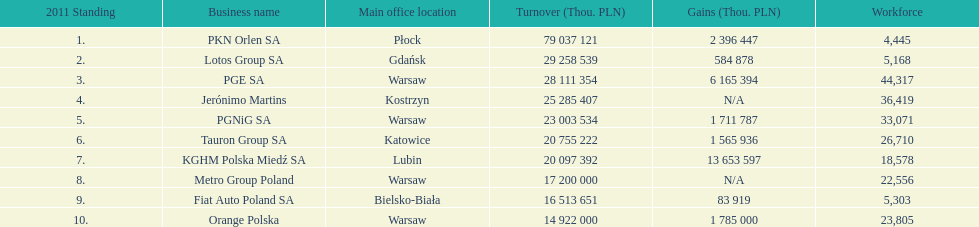What is the number of employees who work for pgnig sa? 33,071. 